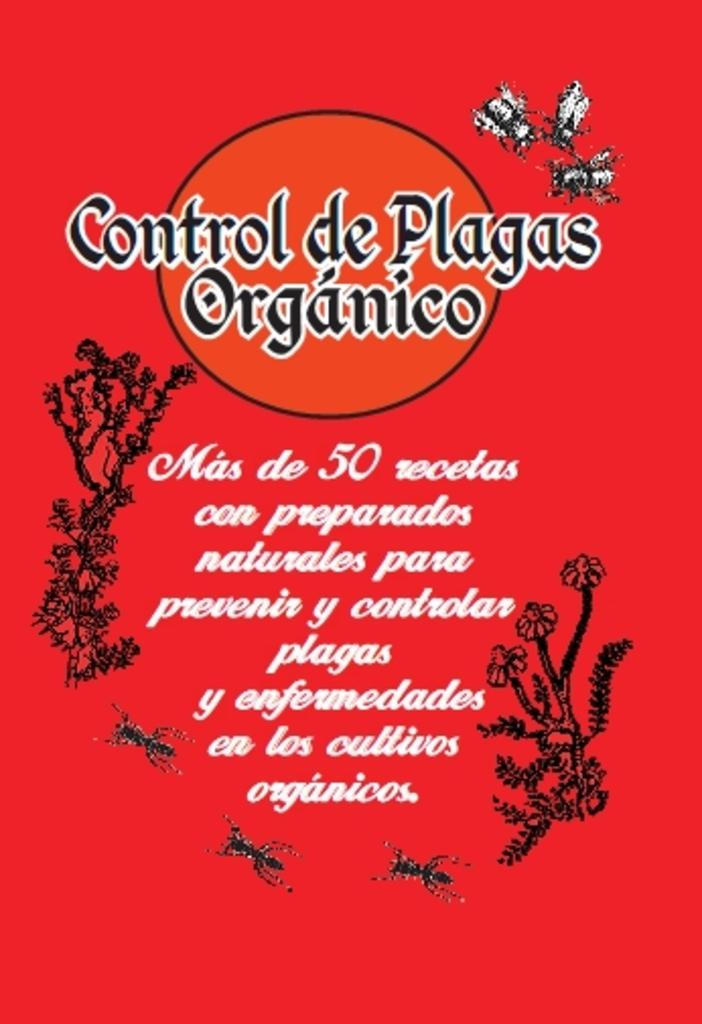What is the main subject of the pamphlet in the image? The pamphlet contains images of insects, flowers, and plants. What type of content can be found on the pamphlet? The pamphlet contains images of insects, flowers, and plants, as well as text written on it. What type of nut is being harvested by the farmer in the image? There is no farmer or nut present in the image; it features a pamphlet with images of insects, flowers, and plants. How does the rainstorm affect the plants in the image? There is no rainstorm present in the image; it features a pamphlet with images of insects, flowers, and plants. 